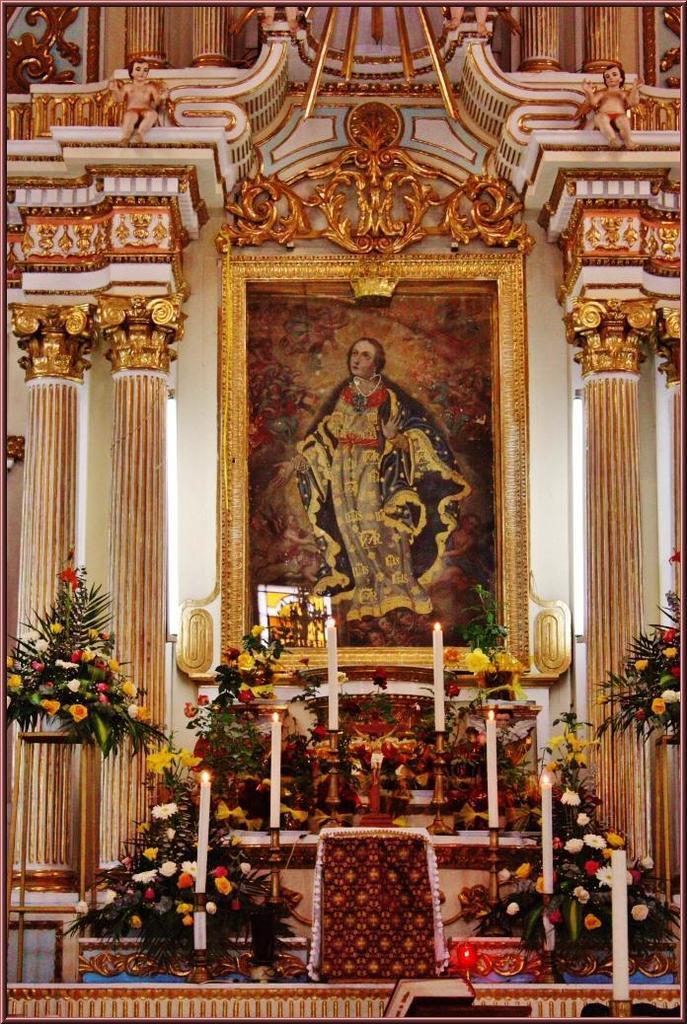How would you summarize this image in a sentence or two? In the center of the image there is a photo frame. In the background we can see flowers, plants and candles. On the right and left side of the image we can see pillars. At the top of the image we can see sculptures and designs. 